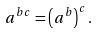<formula> <loc_0><loc_0><loc_500><loc_500>a ^ { b c } = \left ( a ^ { b } \right ) ^ { c } .</formula> 